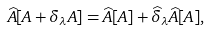Convert formula to latex. <formula><loc_0><loc_0><loc_500><loc_500>\widehat { A } [ A + \delta _ { \lambda } A ] = \widehat { A } [ A ] + \widehat { \delta } _ { \lambda } \widehat { A } [ A ] ,</formula> 